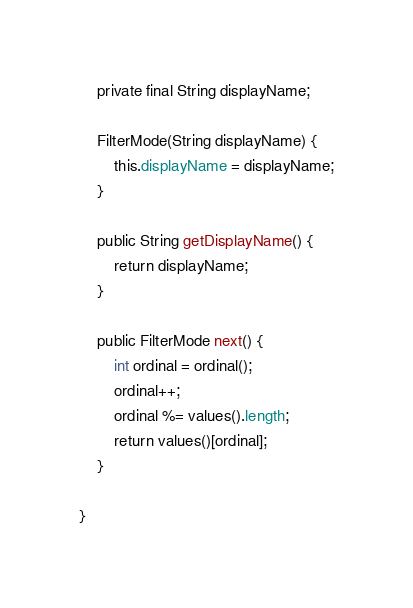<code> <loc_0><loc_0><loc_500><loc_500><_Java_>
    private final String displayName;

    FilterMode(String displayName) {
        this.displayName = displayName;
    }

    public String getDisplayName() {
        return displayName;
    }

    public FilterMode next() {
        int ordinal = ordinal();
        ordinal++;
        ordinal %= values().length;
        return values()[ordinal];
    }

}
</code> 